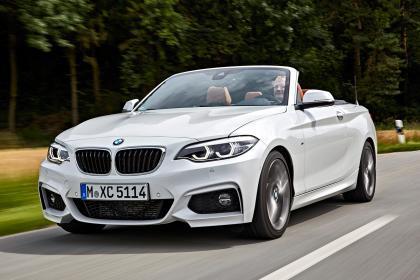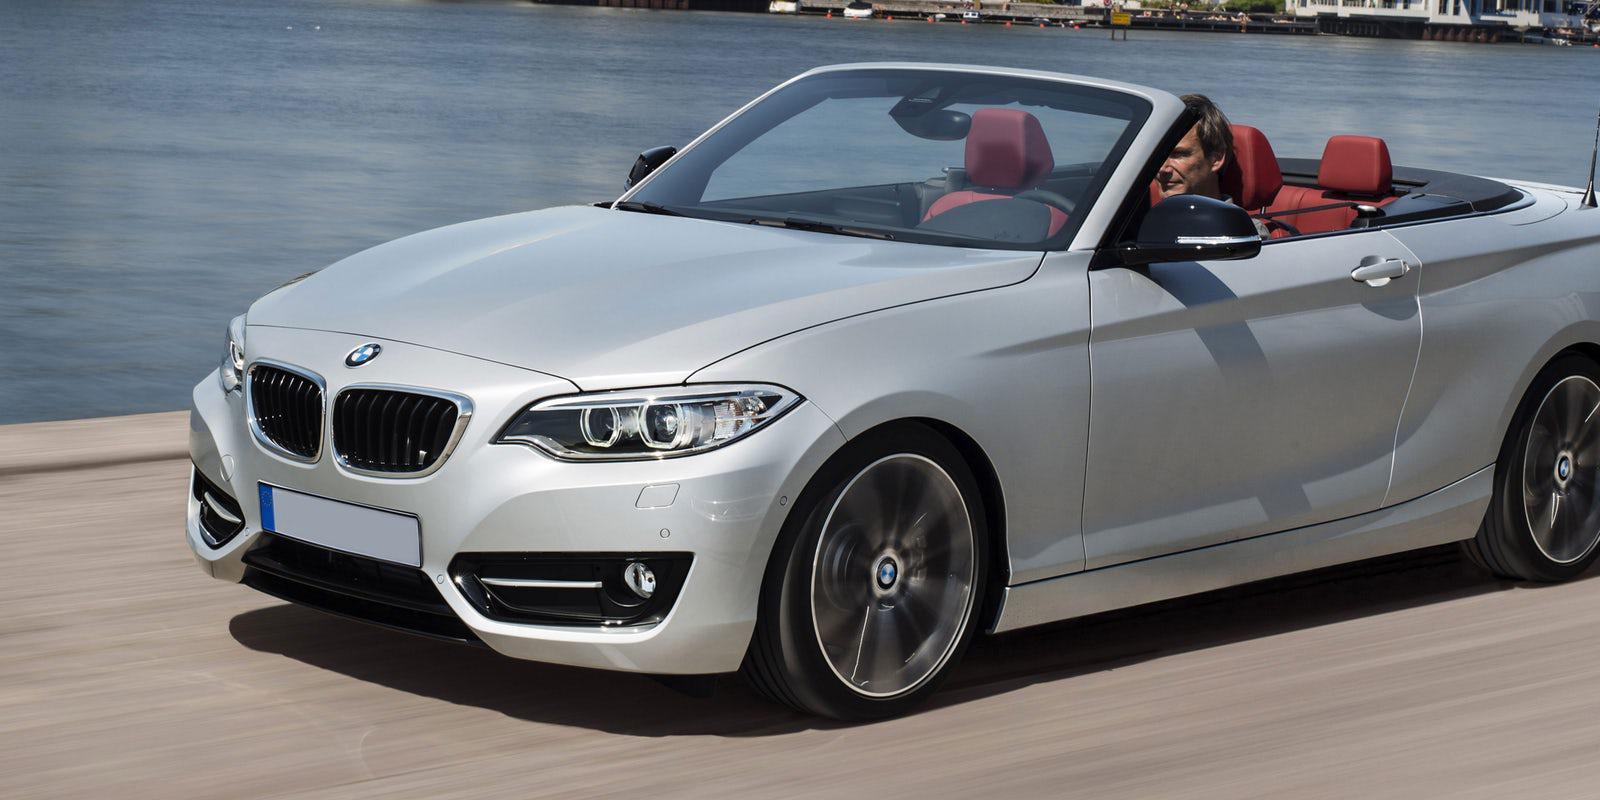The first image is the image on the left, the second image is the image on the right. Assess this claim about the two images: "One of ther cars is blue.". Correct or not? Answer yes or no. No. The first image is the image on the left, the second image is the image on the right. Considering the images on both sides, is "Left image shows a white convertible driving down a paved road." valid? Answer yes or no. Yes. 